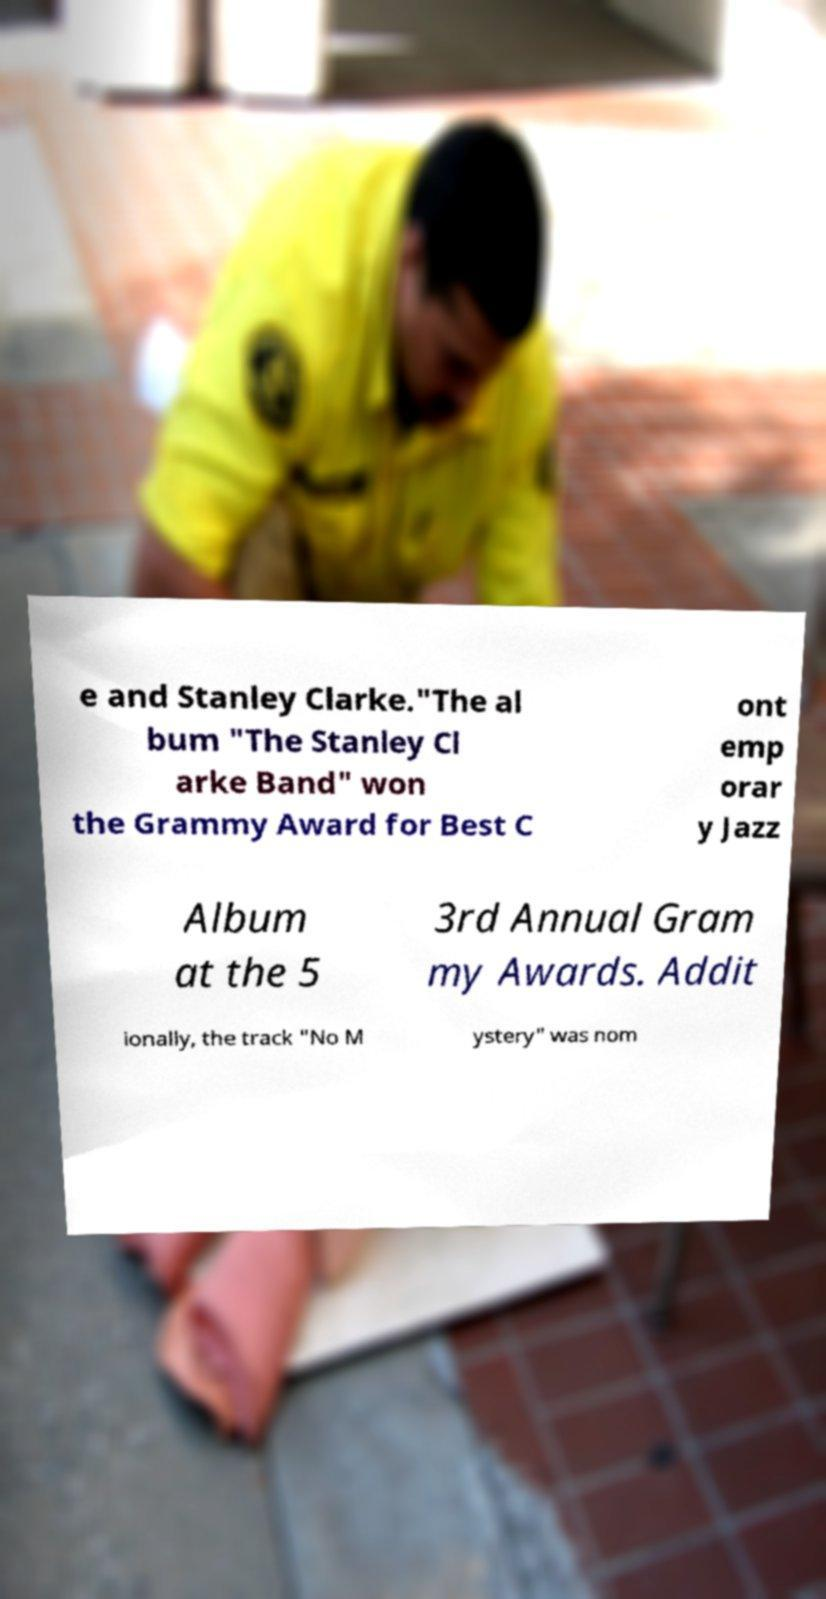For documentation purposes, I need the text within this image transcribed. Could you provide that? e and Stanley Clarke."The al bum "The Stanley Cl arke Band" won the Grammy Award for Best C ont emp orar y Jazz Album at the 5 3rd Annual Gram my Awards. Addit ionally, the track "No M ystery" was nom 